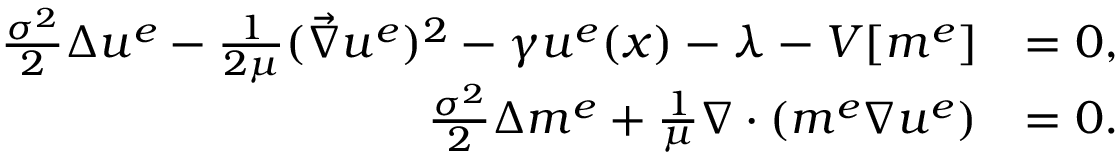<formula> <loc_0><loc_0><loc_500><loc_500>\begin{array} { r l } { \frac { \sigma ^ { 2 } } { 2 } \Delta { u ^ { e } } - \frac { 1 } { 2 \mu } ( \vec { \nabla } u ^ { e } ) ^ { 2 } - \gamma u ^ { e } ( x ) - \lambda - V [ m ^ { e } ] } & { = 0 , } \\ { \frac { \sigma ^ { 2 } } { 2 } \Delta m ^ { e } + \frac { 1 } { \mu } \nabla \cdot ( m ^ { e } \nabla u ^ { e } ) } & { = 0 . } \end{array}</formula> 